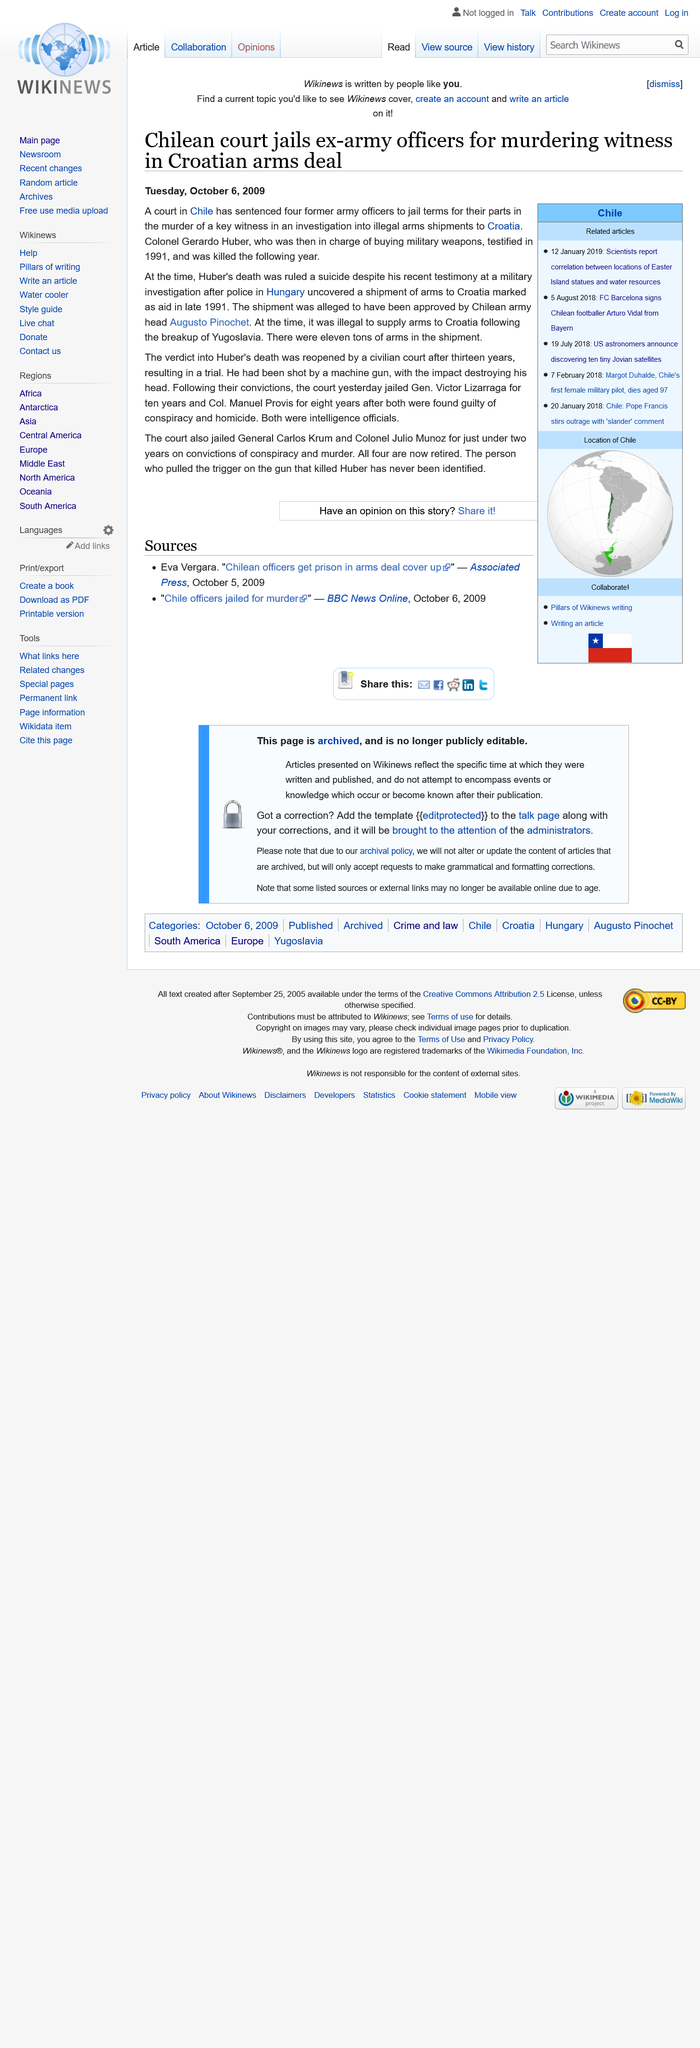Identify some key points in this picture. A court in Chile sentenced four former army officers to prison for their roles in human rights abuses during the country's military dictatorship. The article was published on Tuesday, October 6th, 2009. General Carlos Krum and Colonel Julio Munoz were imprisoned for a period of approximately 20 months. 